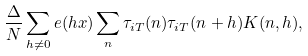<formula> <loc_0><loc_0><loc_500><loc_500>\frac { \Delta } { N } \sum _ { h \neq 0 } e ( h x ) \sum _ { n } \tau _ { i T } ( n ) \tau _ { i T } ( n + h ) K ( n , h ) ,</formula> 